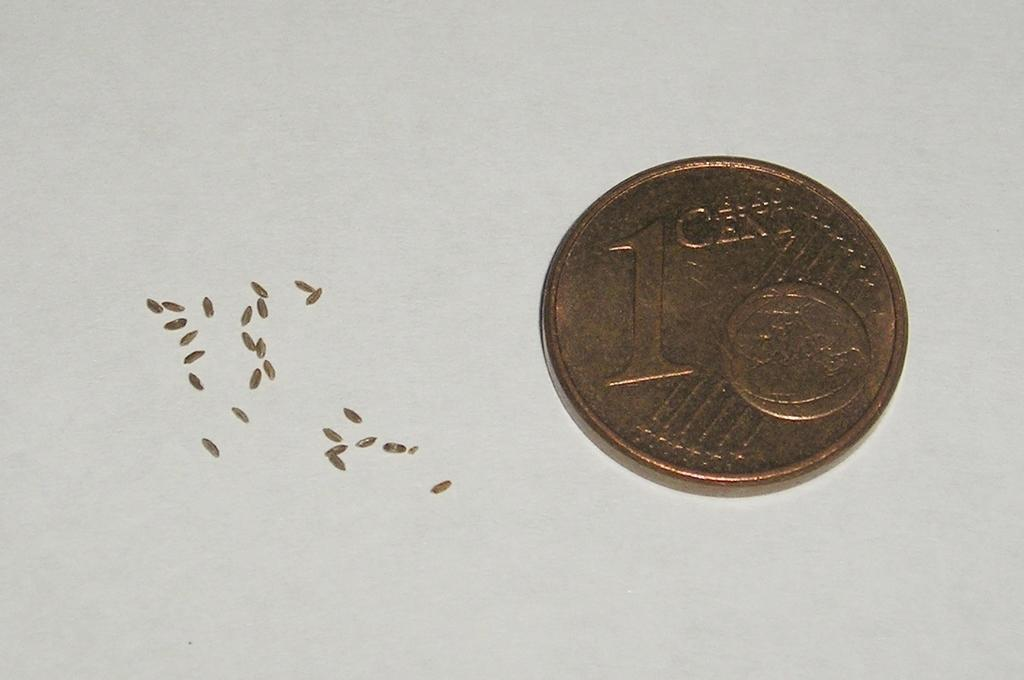<image>
Provide a brief description of the given image. A copper colored 1 cent piece next to some small grains. 